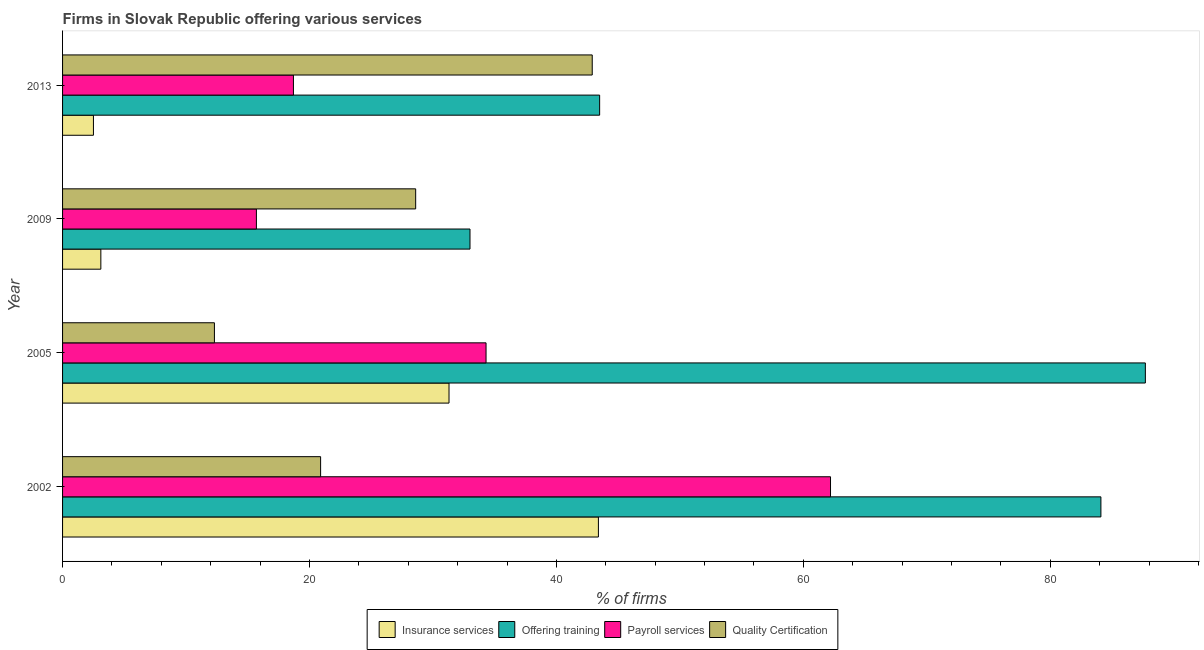How many different coloured bars are there?
Offer a very short reply. 4. How many groups of bars are there?
Give a very brief answer. 4. Are the number of bars per tick equal to the number of legend labels?
Provide a short and direct response. Yes. How many bars are there on the 3rd tick from the top?
Offer a terse response. 4. What is the label of the 3rd group of bars from the top?
Your answer should be compact. 2005. What is the percentage of firms offering payroll services in 2013?
Make the answer very short. 18.7. Across all years, what is the maximum percentage of firms offering payroll services?
Make the answer very short. 62.2. Across all years, what is the minimum percentage of firms offering quality certification?
Give a very brief answer. 12.3. What is the total percentage of firms offering quality certification in the graph?
Give a very brief answer. 104.7. What is the average percentage of firms offering training per year?
Make the answer very short. 62.08. In the year 2013, what is the difference between the percentage of firms offering insurance services and percentage of firms offering training?
Keep it short and to the point. -41. What is the ratio of the percentage of firms offering payroll services in 2002 to that in 2005?
Offer a terse response. 1.81. What is the difference between the highest and the second highest percentage of firms offering quality certification?
Your response must be concise. 14.3. What is the difference between the highest and the lowest percentage of firms offering training?
Offer a very short reply. 54.7. What does the 4th bar from the top in 2013 represents?
Ensure brevity in your answer.  Insurance services. What does the 3rd bar from the bottom in 2002 represents?
Give a very brief answer. Payroll services. Is it the case that in every year, the sum of the percentage of firms offering insurance services and percentage of firms offering training is greater than the percentage of firms offering payroll services?
Offer a terse response. Yes. How many years are there in the graph?
Your answer should be very brief. 4. What is the difference between two consecutive major ticks on the X-axis?
Your response must be concise. 20. Does the graph contain any zero values?
Offer a terse response. No. Does the graph contain grids?
Ensure brevity in your answer.  No. Where does the legend appear in the graph?
Give a very brief answer. Bottom center. What is the title of the graph?
Give a very brief answer. Firms in Slovak Republic offering various services . What is the label or title of the X-axis?
Offer a very short reply. % of firms. What is the % of firms of Insurance services in 2002?
Offer a terse response. 43.4. What is the % of firms of Offering training in 2002?
Provide a short and direct response. 84.1. What is the % of firms in Payroll services in 2002?
Offer a terse response. 62.2. What is the % of firms in Quality Certification in 2002?
Offer a terse response. 20.9. What is the % of firms of Insurance services in 2005?
Your answer should be compact. 31.3. What is the % of firms in Offering training in 2005?
Offer a terse response. 87.7. What is the % of firms of Payroll services in 2005?
Your response must be concise. 34.3. What is the % of firms of Insurance services in 2009?
Make the answer very short. 3.1. What is the % of firms of Offering training in 2009?
Give a very brief answer. 33. What is the % of firms in Quality Certification in 2009?
Ensure brevity in your answer.  28.6. What is the % of firms in Offering training in 2013?
Provide a short and direct response. 43.5. What is the % of firms in Payroll services in 2013?
Your answer should be very brief. 18.7. What is the % of firms of Quality Certification in 2013?
Your answer should be compact. 42.9. Across all years, what is the maximum % of firms of Insurance services?
Your answer should be compact. 43.4. Across all years, what is the maximum % of firms in Offering training?
Your response must be concise. 87.7. Across all years, what is the maximum % of firms in Payroll services?
Give a very brief answer. 62.2. Across all years, what is the maximum % of firms of Quality Certification?
Offer a terse response. 42.9. Across all years, what is the minimum % of firms of Quality Certification?
Your answer should be compact. 12.3. What is the total % of firms in Insurance services in the graph?
Ensure brevity in your answer.  80.3. What is the total % of firms of Offering training in the graph?
Offer a terse response. 248.3. What is the total % of firms in Payroll services in the graph?
Keep it short and to the point. 130.9. What is the total % of firms in Quality Certification in the graph?
Your response must be concise. 104.7. What is the difference between the % of firms of Payroll services in 2002 and that in 2005?
Your response must be concise. 27.9. What is the difference between the % of firms in Insurance services in 2002 and that in 2009?
Offer a very short reply. 40.3. What is the difference between the % of firms of Offering training in 2002 and that in 2009?
Make the answer very short. 51.1. What is the difference between the % of firms of Payroll services in 2002 and that in 2009?
Your answer should be compact. 46.5. What is the difference between the % of firms in Quality Certification in 2002 and that in 2009?
Give a very brief answer. -7.7. What is the difference between the % of firms in Insurance services in 2002 and that in 2013?
Keep it short and to the point. 40.9. What is the difference between the % of firms of Offering training in 2002 and that in 2013?
Offer a terse response. 40.6. What is the difference between the % of firms in Payroll services in 2002 and that in 2013?
Your answer should be compact. 43.5. What is the difference between the % of firms in Quality Certification in 2002 and that in 2013?
Your answer should be very brief. -22. What is the difference between the % of firms in Insurance services in 2005 and that in 2009?
Provide a succinct answer. 28.2. What is the difference between the % of firms in Offering training in 2005 and that in 2009?
Provide a short and direct response. 54.7. What is the difference between the % of firms in Quality Certification in 2005 and that in 2009?
Make the answer very short. -16.3. What is the difference between the % of firms of Insurance services in 2005 and that in 2013?
Make the answer very short. 28.8. What is the difference between the % of firms in Offering training in 2005 and that in 2013?
Your answer should be very brief. 44.2. What is the difference between the % of firms in Quality Certification in 2005 and that in 2013?
Make the answer very short. -30.6. What is the difference between the % of firms in Offering training in 2009 and that in 2013?
Provide a short and direct response. -10.5. What is the difference between the % of firms in Quality Certification in 2009 and that in 2013?
Provide a short and direct response. -14.3. What is the difference between the % of firms in Insurance services in 2002 and the % of firms in Offering training in 2005?
Keep it short and to the point. -44.3. What is the difference between the % of firms in Insurance services in 2002 and the % of firms in Quality Certification in 2005?
Provide a short and direct response. 31.1. What is the difference between the % of firms of Offering training in 2002 and the % of firms of Payroll services in 2005?
Your answer should be compact. 49.8. What is the difference between the % of firms of Offering training in 2002 and the % of firms of Quality Certification in 2005?
Provide a succinct answer. 71.8. What is the difference between the % of firms in Payroll services in 2002 and the % of firms in Quality Certification in 2005?
Make the answer very short. 49.9. What is the difference between the % of firms in Insurance services in 2002 and the % of firms in Offering training in 2009?
Offer a terse response. 10.4. What is the difference between the % of firms of Insurance services in 2002 and the % of firms of Payroll services in 2009?
Provide a succinct answer. 27.7. What is the difference between the % of firms of Insurance services in 2002 and the % of firms of Quality Certification in 2009?
Ensure brevity in your answer.  14.8. What is the difference between the % of firms in Offering training in 2002 and the % of firms in Payroll services in 2009?
Your answer should be compact. 68.4. What is the difference between the % of firms of Offering training in 2002 and the % of firms of Quality Certification in 2009?
Provide a short and direct response. 55.5. What is the difference between the % of firms of Payroll services in 2002 and the % of firms of Quality Certification in 2009?
Provide a succinct answer. 33.6. What is the difference between the % of firms of Insurance services in 2002 and the % of firms of Offering training in 2013?
Your response must be concise. -0.1. What is the difference between the % of firms of Insurance services in 2002 and the % of firms of Payroll services in 2013?
Give a very brief answer. 24.7. What is the difference between the % of firms of Insurance services in 2002 and the % of firms of Quality Certification in 2013?
Keep it short and to the point. 0.5. What is the difference between the % of firms of Offering training in 2002 and the % of firms of Payroll services in 2013?
Your answer should be compact. 65.4. What is the difference between the % of firms of Offering training in 2002 and the % of firms of Quality Certification in 2013?
Your answer should be compact. 41.2. What is the difference between the % of firms in Payroll services in 2002 and the % of firms in Quality Certification in 2013?
Make the answer very short. 19.3. What is the difference between the % of firms of Insurance services in 2005 and the % of firms of Offering training in 2009?
Offer a very short reply. -1.7. What is the difference between the % of firms of Insurance services in 2005 and the % of firms of Quality Certification in 2009?
Your response must be concise. 2.7. What is the difference between the % of firms in Offering training in 2005 and the % of firms in Quality Certification in 2009?
Give a very brief answer. 59.1. What is the difference between the % of firms in Insurance services in 2005 and the % of firms in Offering training in 2013?
Make the answer very short. -12.2. What is the difference between the % of firms of Insurance services in 2005 and the % of firms of Quality Certification in 2013?
Your response must be concise. -11.6. What is the difference between the % of firms in Offering training in 2005 and the % of firms in Payroll services in 2013?
Make the answer very short. 69. What is the difference between the % of firms in Offering training in 2005 and the % of firms in Quality Certification in 2013?
Offer a very short reply. 44.8. What is the difference between the % of firms in Insurance services in 2009 and the % of firms in Offering training in 2013?
Provide a short and direct response. -40.4. What is the difference between the % of firms in Insurance services in 2009 and the % of firms in Payroll services in 2013?
Your answer should be compact. -15.6. What is the difference between the % of firms of Insurance services in 2009 and the % of firms of Quality Certification in 2013?
Provide a short and direct response. -39.8. What is the difference between the % of firms in Payroll services in 2009 and the % of firms in Quality Certification in 2013?
Your response must be concise. -27.2. What is the average % of firms of Insurance services per year?
Your response must be concise. 20.07. What is the average % of firms of Offering training per year?
Give a very brief answer. 62.08. What is the average % of firms in Payroll services per year?
Provide a short and direct response. 32.73. What is the average % of firms of Quality Certification per year?
Keep it short and to the point. 26.18. In the year 2002, what is the difference between the % of firms of Insurance services and % of firms of Offering training?
Your answer should be very brief. -40.7. In the year 2002, what is the difference between the % of firms of Insurance services and % of firms of Payroll services?
Give a very brief answer. -18.8. In the year 2002, what is the difference between the % of firms of Offering training and % of firms of Payroll services?
Provide a succinct answer. 21.9. In the year 2002, what is the difference between the % of firms of Offering training and % of firms of Quality Certification?
Ensure brevity in your answer.  63.2. In the year 2002, what is the difference between the % of firms in Payroll services and % of firms in Quality Certification?
Offer a very short reply. 41.3. In the year 2005, what is the difference between the % of firms in Insurance services and % of firms in Offering training?
Offer a terse response. -56.4. In the year 2005, what is the difference between the % of firms in Offering training and % of firms in Payroll services?
Provide a succinct answer. 53.4. In the year 2005, what is the difference between the % of firms in Offering training and % of firms in Quality Certification?
Your answer should be very brief. 75.4. In the year 2005, what is the difference between the % of firms in Payroll services and % of firms in Quality Certification?
Ensure brevity in your answer.  22. In the year 2009, what is the difference between the % of firms in Insurance services and % of firms in Offering training?
Your answer should be compact. -29.9. In the year 2009, what is the difference between the % of firms in Insurance services and % of firms in Payroll services?
Your answer should be compact. -12.6. In the year 2009, what is the difference between the % of firms of Insurance services and % of firms of Quality Certification?
Provide a short and direct response. -25.5. In the year 2009, what is the difference between the % of firms in Offering training and % of firms in Quality Certification?
Provide a short and direct response. 4.4. In the year 2013, what is the difference between the % of firms in Insurance services and % of firms in Offering training?
Offer a very short reply. -41. In the year 2013, what is the difference between the % of firms in Insurance services and % of firms in Payroll services?
Keep it short and to the point. -16.2. In the year 2013, what is the difference between the % of firms of Insurance services and % of firms of Quality Certification?
Offer a very short reply. -40.4. In the year 2013, what is the difference between the % of firms in Offering training and % of firms in Payroll services?
Offer a very short reply. 24.8. In the year 2013, what is the difference between the % of firms of Payroll services and % of firms of Quality Certification?
Provide a succinct answer. -24.2. What is the ratio of the % of firms of Insurance services in 2002 to that in 2005?
Your response must be concise. 1.39. What is the ratio of the % of firms in Payroll services in 2002 to that in 2005?
Offer a very short reply. 1.81. What is the ratio of the % of firms in Quality Certification in 2002 to that in 2005?
Give a very brief answer. 1.7. What is the ratio of the % of firms of Insurance services in 2002 to that in 2009?
Your answer should be compact. 14. What is the ratio of the % of firms in Offering training in 2002 to that in 2009?
Your answer should be compact. 2.55. What is the ratio of the % of firms of Payroll services in 2002 to that in 2009?
Your answer should be compact. 3.96. What is the ratio of the % of firms of Quality Certification in 2002 to that in 2009?
Your response must be concise. 0.73. What is the ratio of the % of firms in Insurance services in 2002 to that in 2013?
Provide a succinct answer. 17.36. What is the ratio of the % of firms of Offering training in 2002 to that in 2013?
Your answer should be very brief. 1.93. What is the ratio of the % of firms of Payroll services in 2002 to that in 2013?
Make the answer very short. 3.33. What is the ratio of the % of firms of Quality Certification in 2002 to that in 2013?
Ensure brevity in your answer.  0.49. What is the ratio of the % of firms of Insurance services in 2005 to that in 2009?
Provide a succinct answer. 10.1. What is the ratio of the % of firms of Offering training in 2005 to that in 2009?
Provide a short and direct response. 2.66. What is the ratio of the % of firms in Payroll services in 2005 to that in 2009?
Ensure brevity in your answer.  2.18. What is the ratio of the % of firms of Quality Certification in 2005 to that in 2009?
Make the answer very short. 0.43. What is the ratio of the % of firms of Insurance services in 2005 to that in 2013?
Your answer should be compact. 12.52. What is the ratio of the % of firms in Offering training in 2005 to that in 2013?
Ensure brevity in your answer.  2.02. What is the ratio of the % of firms in Payroll services in 2005 to that in 2013?
Your answer should be compact. 1.83. What is the ratio of the % of firms in Quality Certification in 2005 to that in 2013?
Offer a very short reply. 0.29. What is the ratio of the % of firms in Insurance services in 2009 to that in 2013?
Offer a very short reply. 1.24. What is the ratio of the % of firms in Offering training in 2009 to that in 2013?
Provide a short and direct response. 0.76. What is the ratio of the % of firms of Payroll services in 2009 to that in 2013?
Your answer should be compact. 0.84. What is the difference between the highest and the second highest % of firms of Insurance services?
Offer a very short reply. 12.1. What is the difference between the highest and the second highest % of firms of Payroll services?
Ensure brevity in your answer.  27.9. What is the difference between the highest and the second highest % of firms of Quality Certification?
Give a very brief answer. 14.3. What is the difference between the highest and the lowest % of firms in Insurance services?
Your answer should be compact. 40.9. What is the difference between the highest and the lowest % of firms of Offering training?
Keep it short and to the point. 54.7. What is the difference between the highest and the lowest % of firms of Payroll services?
Your answer should be very brief. 46.5. What is the difference between the highest and the lowest % of firms in Quality Certification?
Your response must be concise. 30.6. 